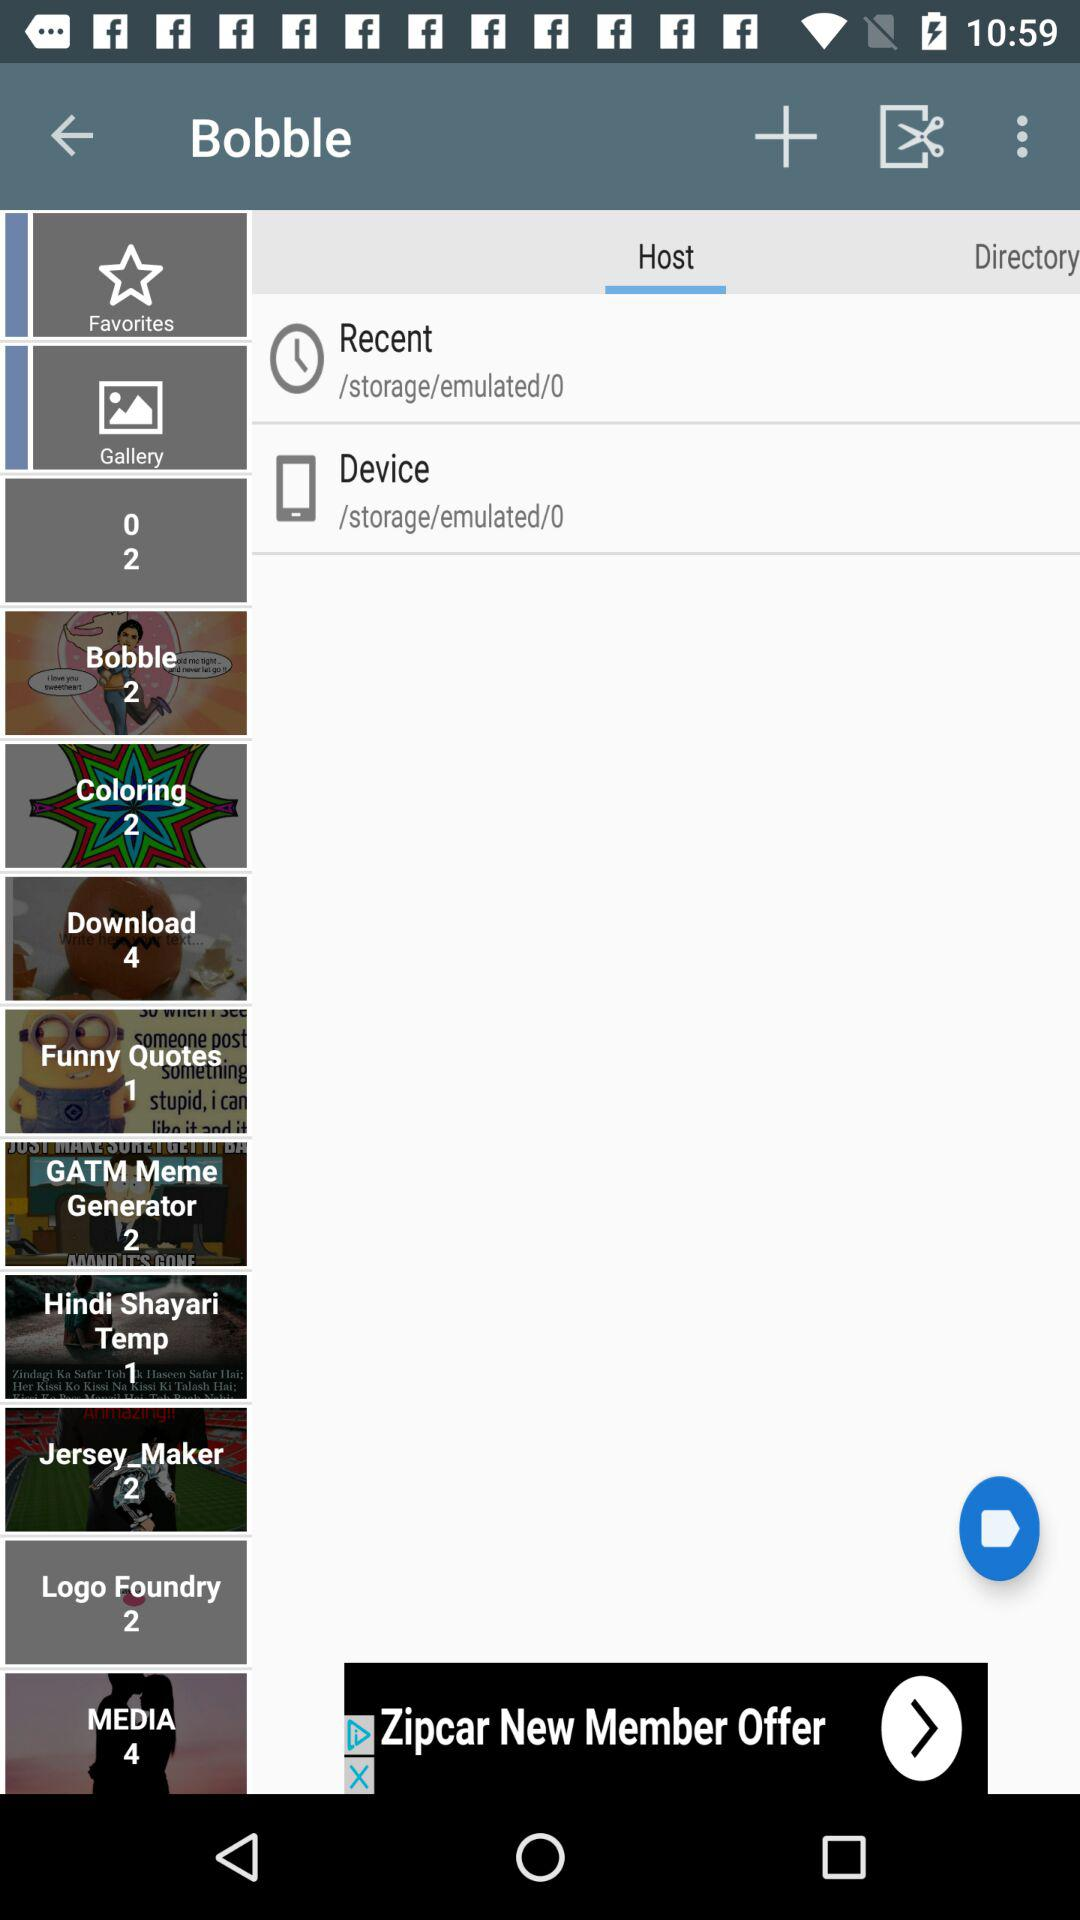How much data is there in logo foundry?
When the provided information is insufficient, respond with <no answer>. <no answer> 